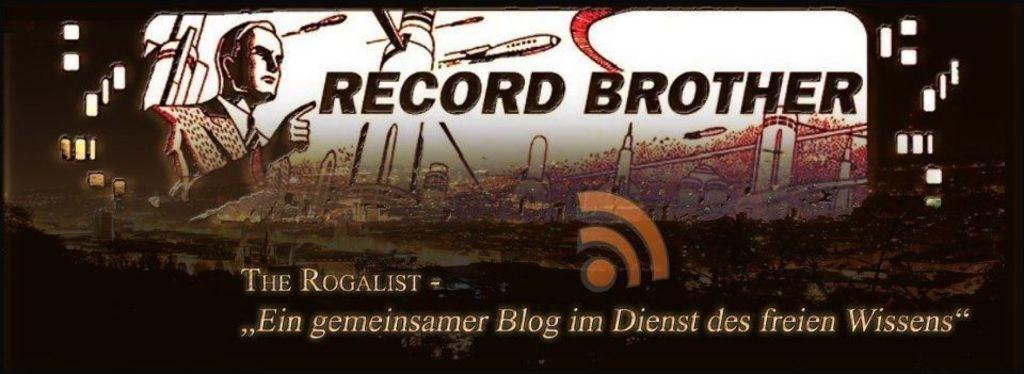<image>
Write a terse but informative summary of the picture. A poster with foreign writing on the bottom 